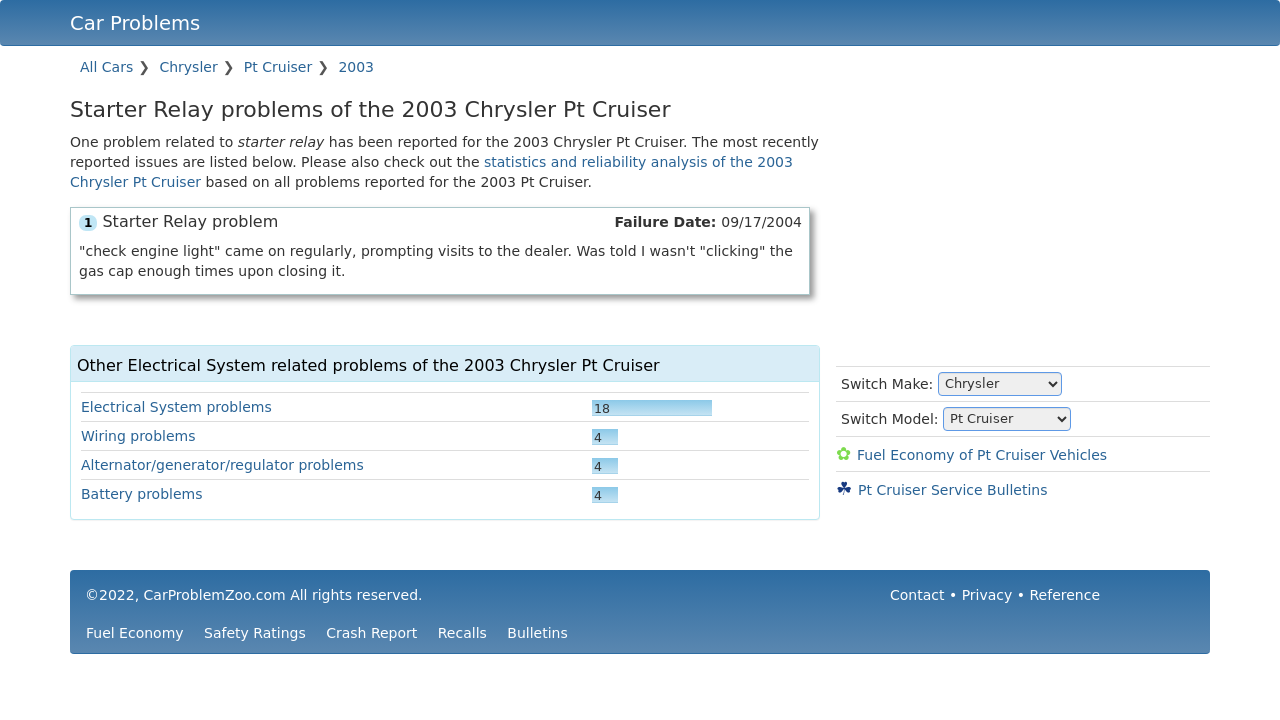Can you tell what solutions are often suggested for the starter relay problems in the 2003 PT Cruiser? For the starter relay problems in the 2003 PT Cruiser, solutions often include checking and replacing the starter relay itself, ensuring that battery connections are clean and secure, and verifying that the ignition switch functions correctly. It's also advised to check for any corrosion at the relay connections. 